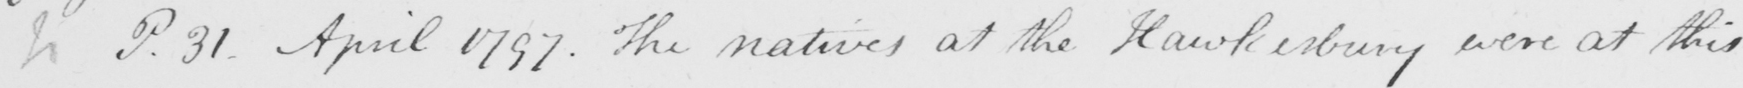Please provide the text content of this handwritten line. P.31 - April 1797 . The natives at the Hawkesbury were at this 